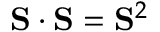<formula> <loc_0><loc_0><loc_500><loc_500>S \cdot S = S ^ { 2 }</formula> 